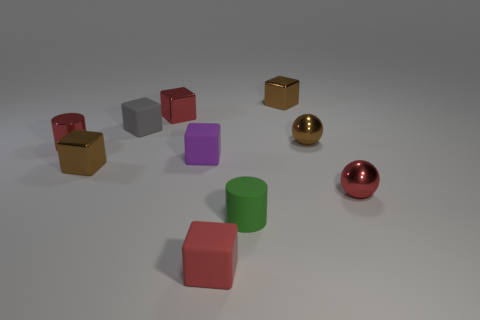There is a brown thing that is on the left side of the tiny purple thing; is it the same shape as the small green rubber object?
Offer a very short reply. No. What number of matte objects are both to the right of the red shiny block and behind the small matte cylinder?
Your response must be concise. 1. How many other things are there of the same size as the purple matte block?
Offer a terse response. 9. Is the number of metallic spheres that are in front of the tiny purple object the same as the number of tiny red things?
Your answer should be compact. No. There is a cylinder left of the green rubber object; does it have the same color as the shiny cube to the left of the small gray block?
Your answer should be compact. No. What is the thing that is in front of the tiny metal cylinder and left of the small gray thing made of?
Make the answer very short. Metal. What is the color of the metallic cylinder?
Give a very brief answer. Red. How many other objects are there of the same shape as the small purple matte thing?
Provide a short and direct response. 5. Are there an equal number of brown cubes behind the small purple rubber cube and tiny red matte cubes that are right of the tiny brown shiny ball?
Give a very brief answer. No. What material is the green object?
Make the answer very short. Rubber. 